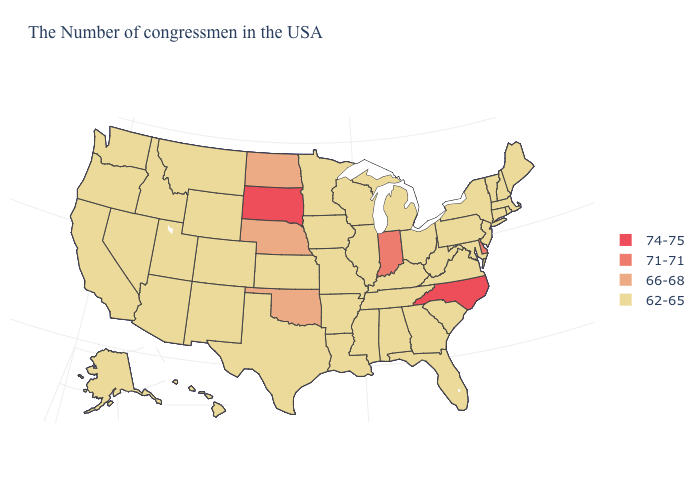How many symbols are there in the legend?
Quick response, please. 4. What is the value of Michigan?
Keep it brief. 62-65. Does Pennsylvania have the lowest value in the USA?
Write a very short answer. Yes. What is the highest value in the USA?
Short answer required. 74-75. What is the lowest value in the USA?
Write a very short answer. 62-65. What is the value of Ohio?
Short answer required. 62-65. What is the value of Idaho?
Answer briefly. 62-65. What is the lowest value in the USA?
Quick response, please. 62-65. Name the states that have a value in the range 66-68?
Answer briefly. Nebraska, Oklahoma, North Dakota. Name the states that have a value in the range 71-71?
Write a very short answer. Delaware, Indiana. What is the value of Indiana?
Write a very short answer. 71-71. Name the states that have a value in the range 62-65?
Concise answer only. Maine, Massachusetts, Rhode Island, New Hampshire, Vermont, Connecticut, New York, New Jersey, Maryland, Pennsylvania, Virginia, South Carolina, West Virginia, Ohio, Florida, Georgia, Michigan, Kentucky, Alabama, Tennessee, Wisconsin, Illinois, Mississippi, Louisiana, Missouri, Arkansas, Minnesota, Iowa, Kansas, Texas, Wyoming, Colorado, New Mexico, Utah, Montana, Arizona, Idaho, Nevada, California, Washington, Oregon, Alaska, Hawaii. Among the states that border Iowa , which have the lowest value?
Give a very brief answer. Wisconsin, Illinois, Missouri, Minnesota. What is the highest value in the USA?
Quick response, please. 74-75. 